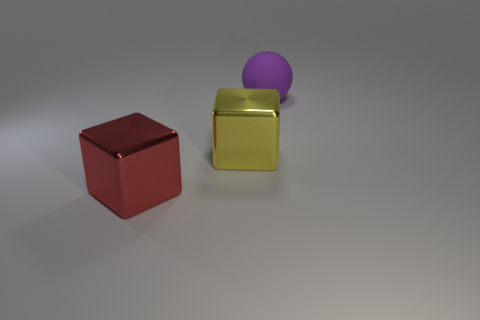What number of things are either large objects in front of the matte thing or big metal objects that are behind the red block?
Provide a short and direct response. 2. What material is the other large object that is the same shape as the big red object?
Provide a succinct answer. Metal. Are any red metal cubes visible?
Make the answer very short. Yes. What shape is the yellow object?
Offer a very short reply. Cube. There is a large yellow thing behind the big red cube; is there a big object to the right of it?
Give a very brief answer. Yes. There is a red cube that is the same size as the sphere; what material is it?
Ensure brevity in your answer.  Metal. Are there any matte things of the same size as the red block?
Ensure brevity in your answer.  Yes. What material is the big thing that is behind the big yellow shiny cube?
Your answer should be very brief. Rubber. Is the material of the large thing on the right side of the big yellow block the same as the red object?
Ensure brevity in your answer.  No. There is a yellow object that is the same size as the red block; what is its shape?
Provide a succinct answer. Cube. 